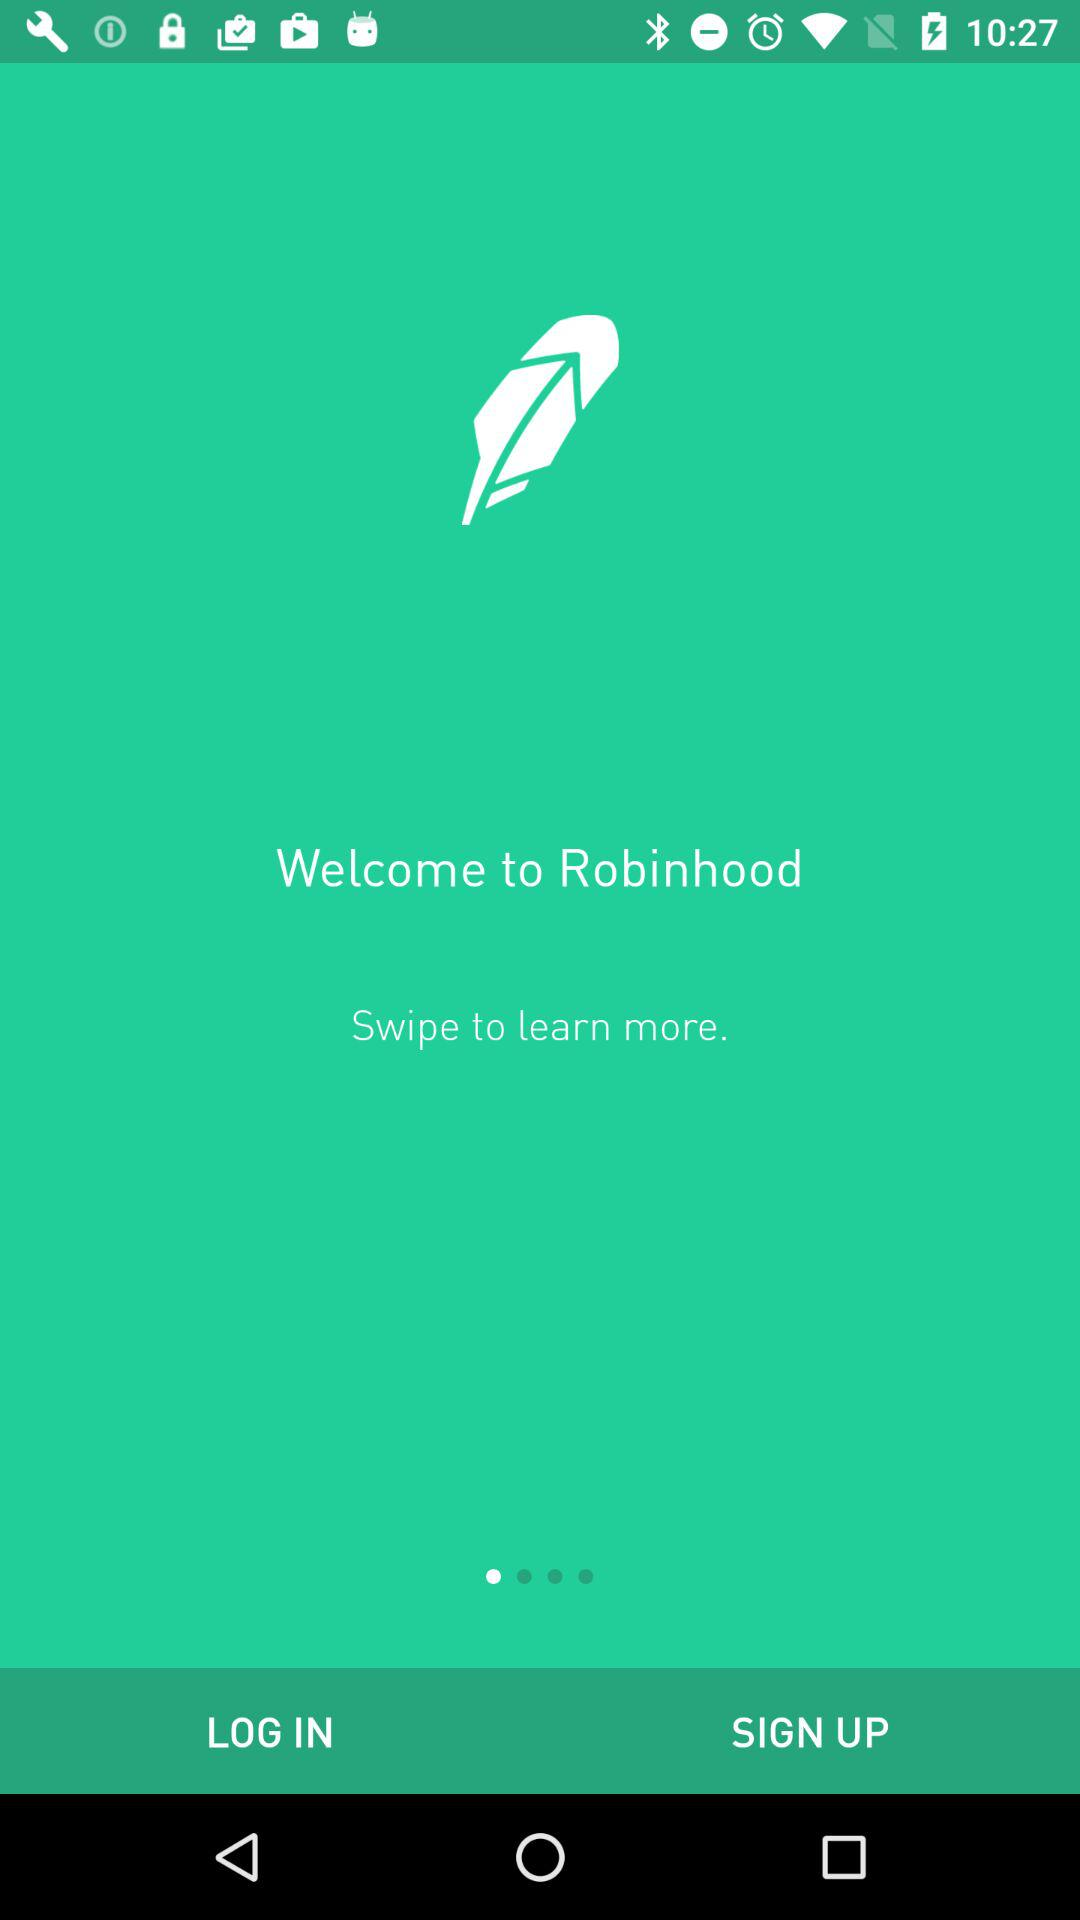What is the application name? The application name is "Robinhood". 